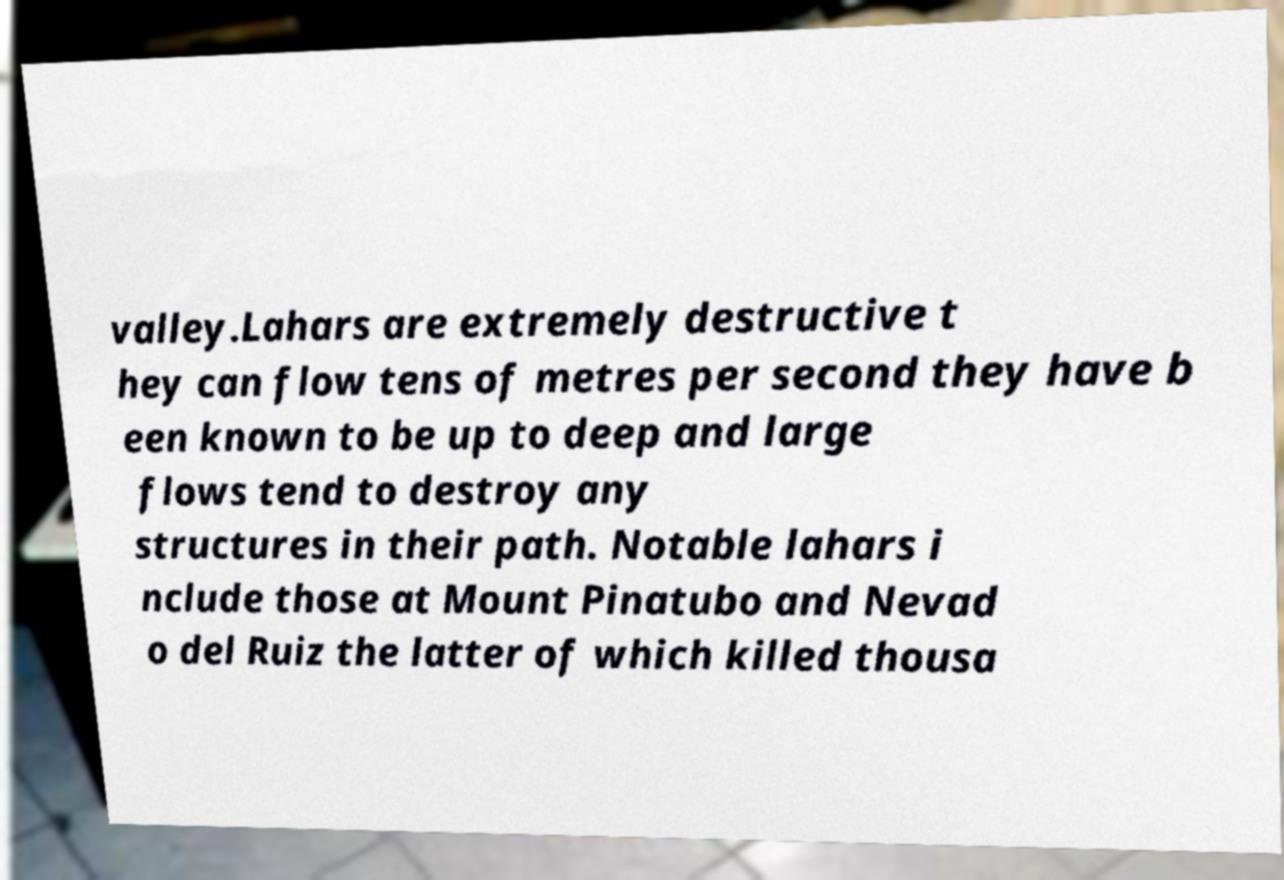Please read and relay the text visible in this image. What does it say? valley.Lahars are extremely destructive t hey can flow tens of metres per second they have b een known to be up to deep and large flows tend to destroy any structures in their path. Notable lahars i nclude those at Mount Pinatubo and Nevad o del Ruiz the latter of which killed thousa 